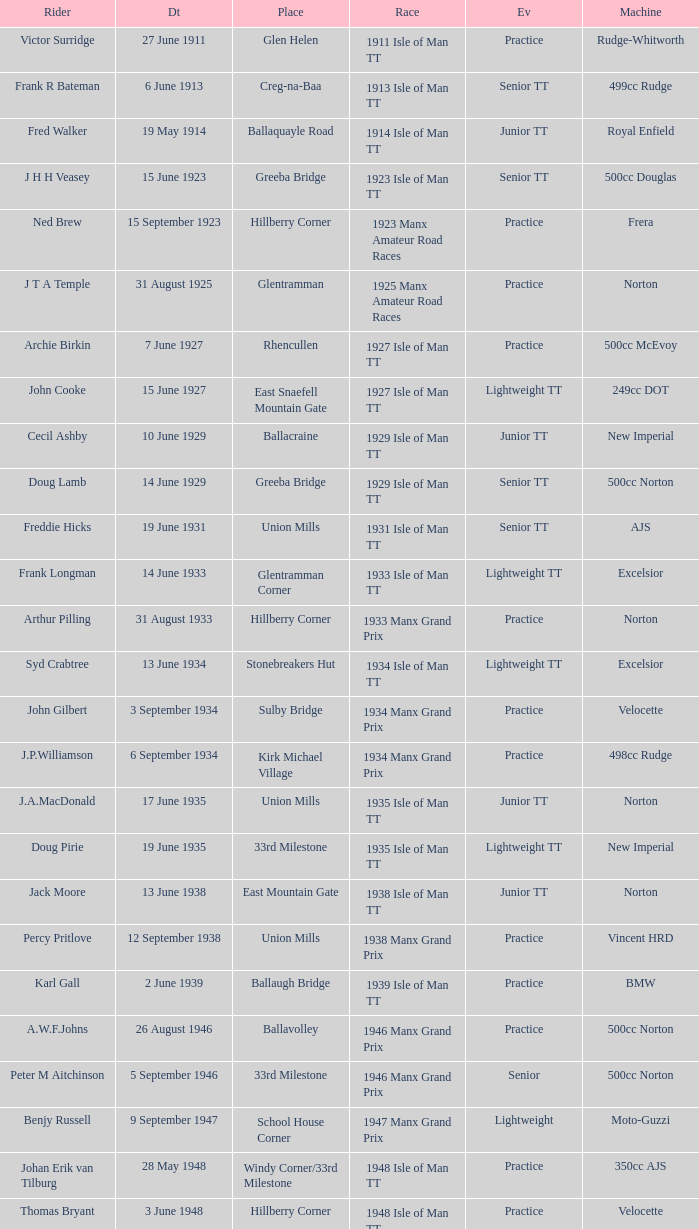Where was the 249cc Yamaha? Glentramman. 